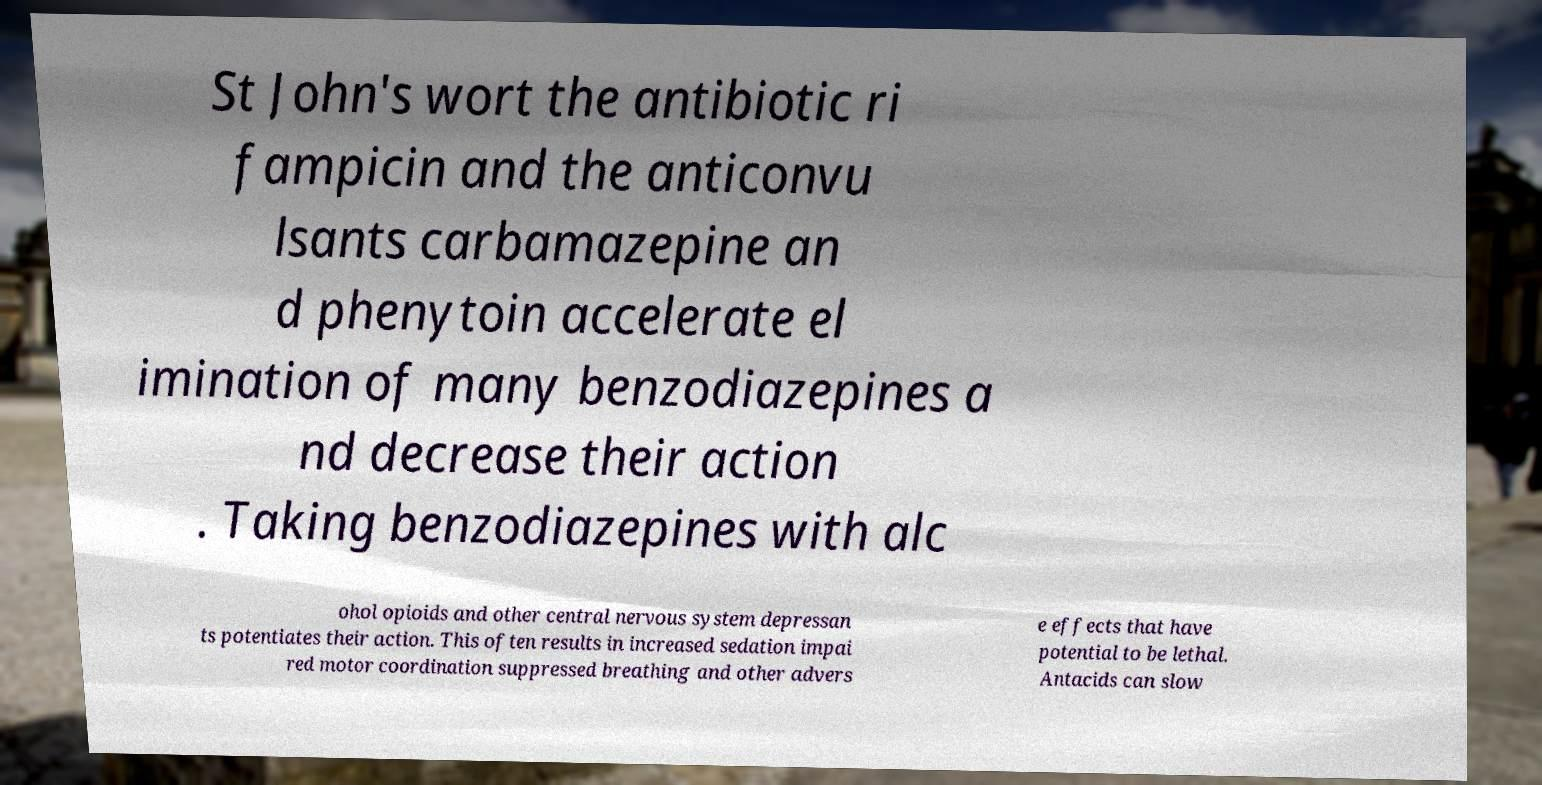Can you accurately transcribe the text from the provided image for me? St John's wort the antibiotic ri fampicin and the anticonvu lsants carbamazepine an d phenytoin accelerate el imination of many benzodiazepines a nd decrease their action . Taking benzodiazepines with alc ohol opioids and other central nervous system depressan ts potentiates their action. This often results in increased sedation impai red motor coordination suppressed breathing and other advers e effects that have potential to be lethal. Antacids can slow 